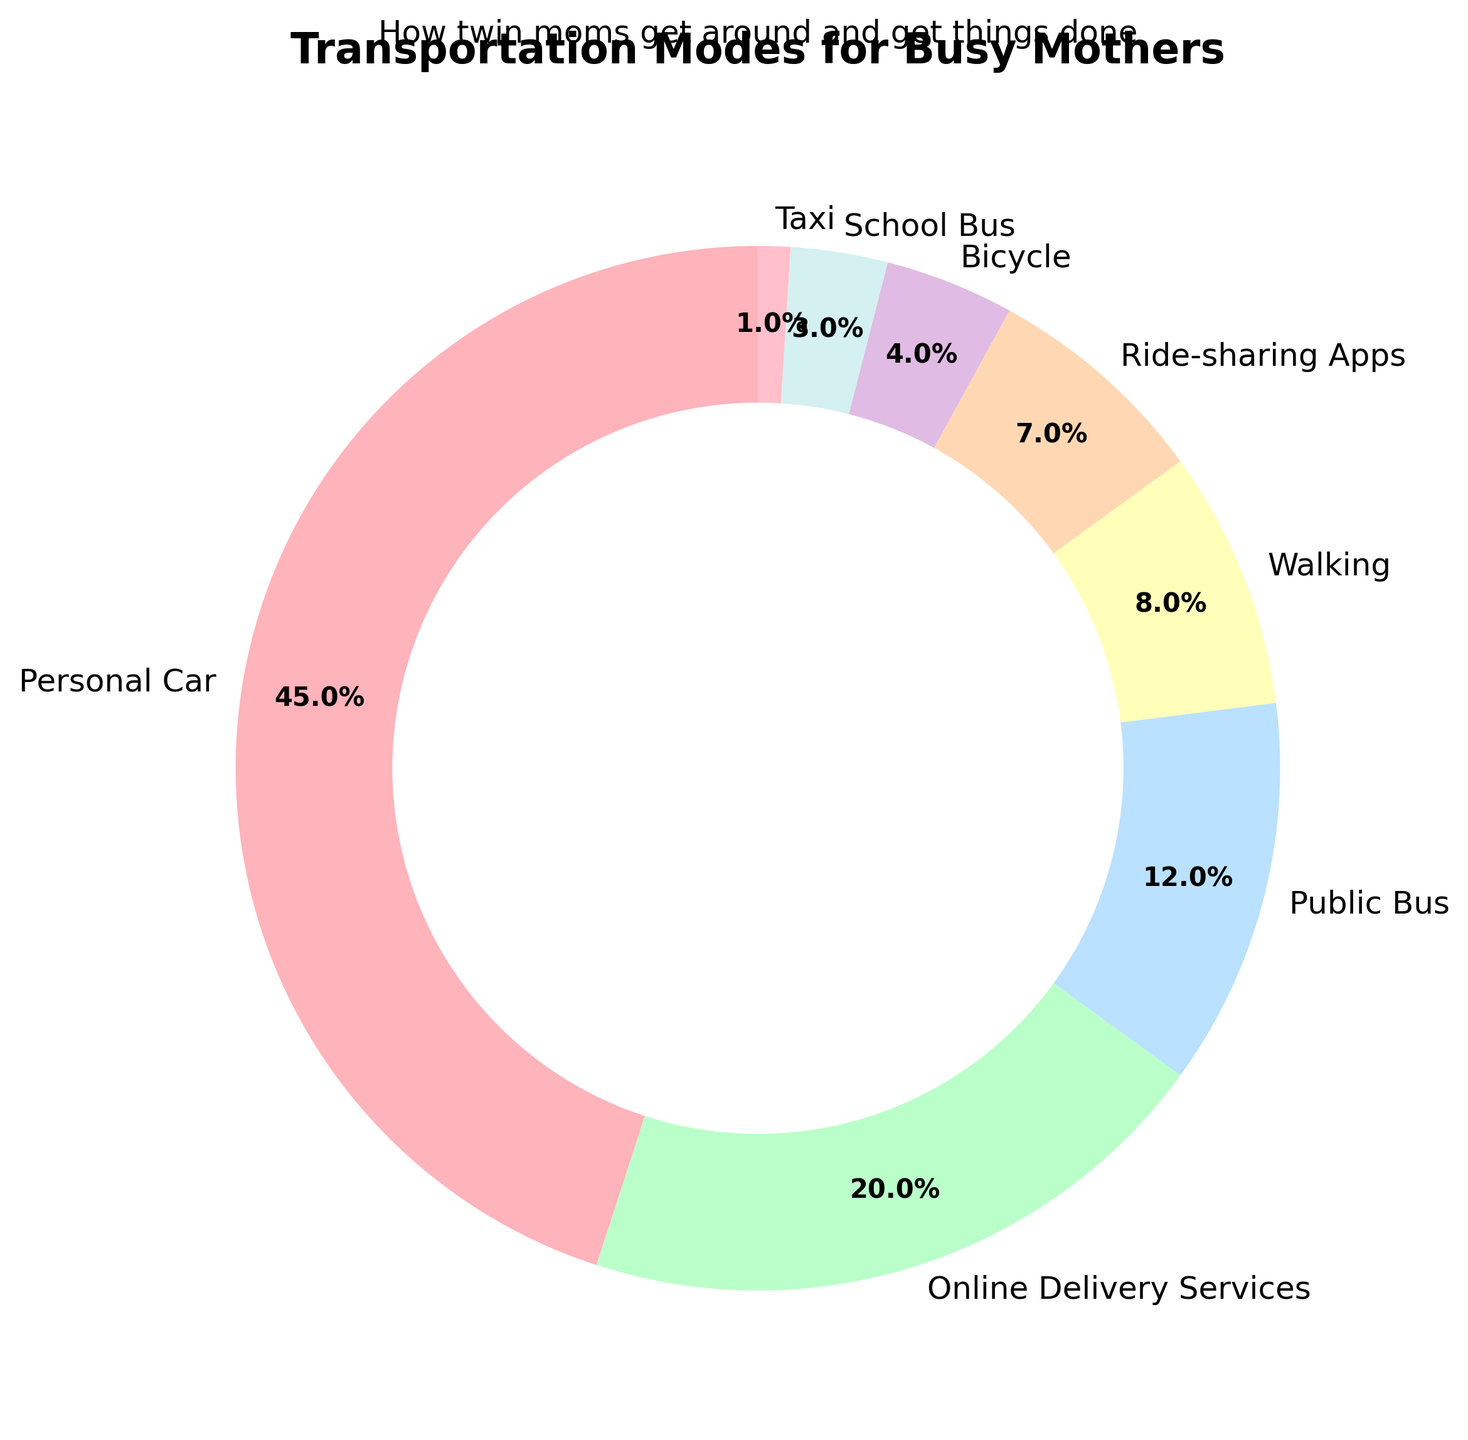What mode of transportation is used the most by busy mothers? The figure shows that the largest slice of the pie chart, representing 45%, is labeled "Personal Car," indicating it is the most used mode of transportation.
Answer: Personal Car What percentage of busy mothers use ride-sharing apps? The slice representing "Ride-sharing Apps" accounts for 7% of the pie chart.
Answer: 7% How much more do busy mothers use personal cars compared to public buses? Personal car usage is 45% and public bus usage is 12%. Subtract the latter from the former: 45% - 12% = 33%.
Answer: 33% Which mode of transportation is used less than bicycles but more than taxis? The pie chart shows the percentages for bicycles and taxis as 4% and 1% respectively. The mode between these two is "School Bus," which accounts for 3%.
Answer: School Bus What two modes of transportation together account for exactly half of the usage? Combining percentages of "Personal Car" (45%) and "Online Delivery Services" (20%) gives 45% + 20% = 65%. However, "Personal Car" (45%) and "Public Bus" (12%) together make 45% + 12% = 57%, which doesn't fit. Therefore, "Personal Car" and "Walking" results in 45% + 8% = 53%, still not fitting exact. Finally, the combination of "Walking" (8%) and "Online Delivery Services" (20%) yields 8% + 20% = 28%. It seems non form exact 50%. So, instead closest {45, 20, 7, 8, 4, 3} combinations <55%.  Personal Car, Online Delivery Service
Answer: {N/A} How many times more do busy mothers use personal cars compared to ride-sharing apps? Personal car usage is 45% and ride-sharing apps’ usage is 7%. Dividing the former by the latter, 45% / 7% ≈ 6.43.
Answer: ~6.43 times What is the combined percentage of mothers using bicycles, school buses, and walking? Adding the percentages for "Bicycle" (4%), "School Bus" (3%), and "Walking" (8%): 4% + 3% + 8% = 15%.
Answer: 15% Which has a higher percentage, ride-sharing apps or public buses? Ride-sharing apps account for 7% while public buses account for 12%. Public buses have a higher percentage.
Answer: Public Buses List the modes of transportation in descending order of usage. The percentage values on the pie chart indicate the following order from highest to lowest: Personal Car (45%), Online Delivery Services (20%), Public Bus (12%), Walking (8%), Ride-sharing Apps (7%), Bicycle (4%), School Bus (3%), Taxi (1%).
Answer: Personal Car, Online Delivery Services, Public Bus, Walking, Ride-sharing Apps, Bicycle, School Bus, Taxi 